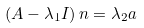Convert formula to latex. <formula><loc_0><loc_0><loc_500><loc_500>\left ( { { A } - \lambda _ { 1 } { I } } \right ) { n } = \lambda _ { 2 } { a }</formula> 